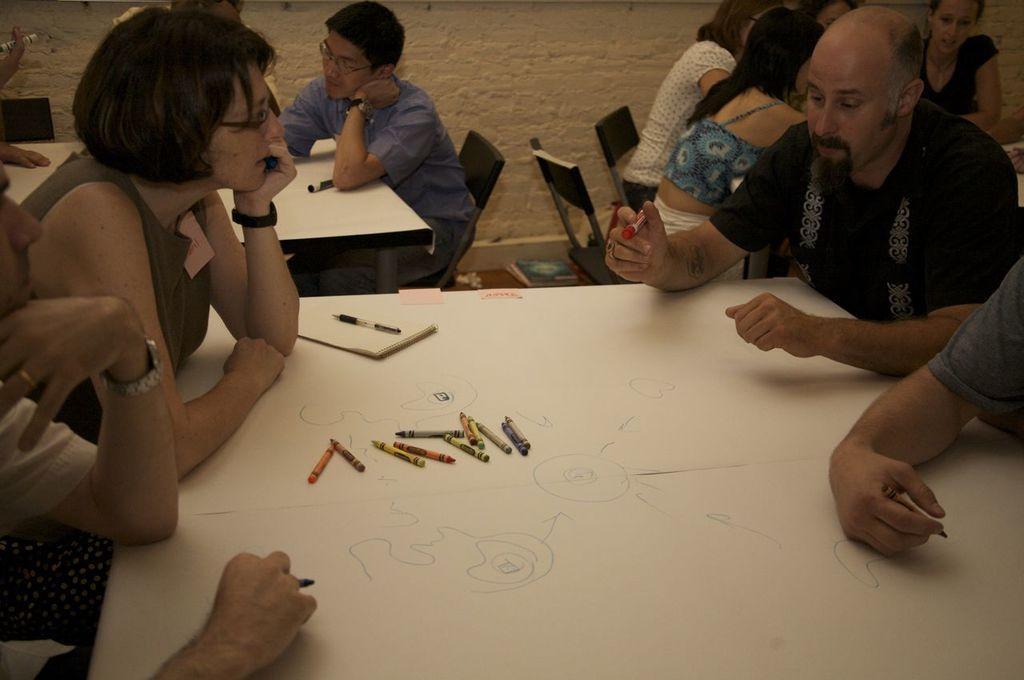Could you give a brief overview of what you see in this image? Here we can see few persons were sitting on the chair in front of there tables. On table we can see some objects. Coming to the right side one man he is holding one marker in his hand. Coming to the background we can see the wall. 